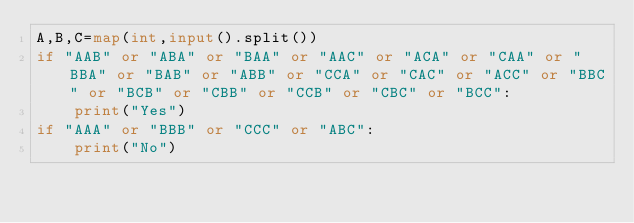<code> <loc_0><loc_0><loc_500><loc_500><_Python_>A,B,C=map(int,input().split())
if "AAB" or "ABA" or "BAA" or "AAC" or "ACA" or "CAA" or "BBA" or "BAB" or "ABB" or "CCA" or "CAC" or "ACC" or "BBC" or "BCB" or "CBB" or "CCB" or "CBC" or "BCC":
    print("Yes")
if "AAA" or "BBB" or "CCC" or "ABC":
    print("No")</code> 